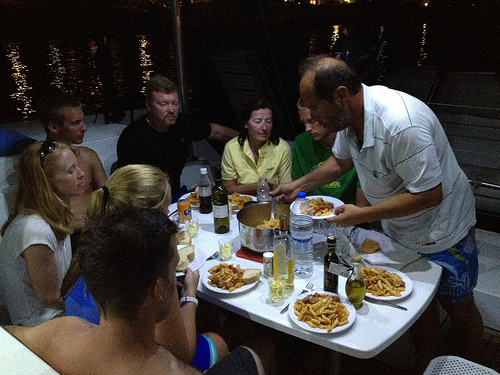Please provide a short description for this region: [0.57, 0.5, 0.63, 0.7]. The selected region features a tall, slender bottle filled with water, set among other dining essentials on a white table, reflecting a relaxed dining atmosphere. 